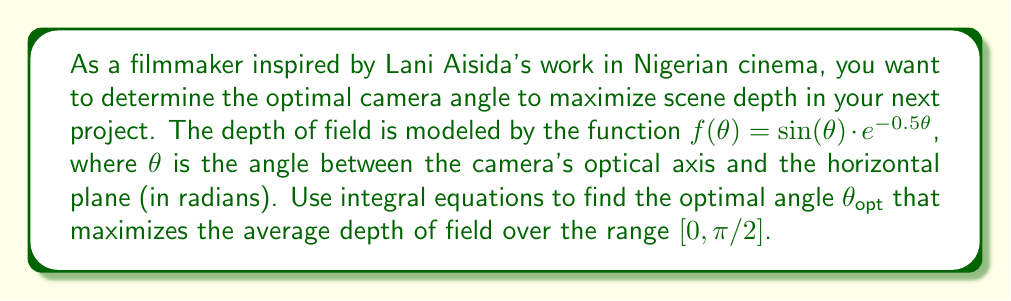What is the answer to this math problem? To find the optimal angle, we need to maximize the average depth of field over the given range. This can be formulated as an integral equation:

1. The average depth of field is given by:
   $$\text{Average Depth} = \frac{1}{\pi/2} \int_0^{\pi/2} f(\theta) d\theta$$

2. Substitute the given function:
   $$\text{Average Depth} = \frac{2}{\pi} \int_0^{\pi/2} \sin(\theta) \cdot e^{-0.5\theta} d\theta$$

3. To find the maximum, we need to differentiate this with respect to $\theta$ and set it to zero:
   $$\frac{d}{d\theta}\left(\frac{2}{\pi} \int_0^{\pi/2} \sin(\theta) \cdot e^{-0.5\theta} d\theta\right) = 0$$

4. Using the Fundamental Theorem of Calculus:
   $$\frac{2}{\pi} \cdot \sin(\theta) \cdot e^{-0.5\theta} = 0$$

5. Solving this equation:
   $$\sin(\theta) \cdot e^{-0.5\theta} = 0$$

6. This is satisfied when $\sin(\theta) = 0$ or when $\theta \to \infty$. In our range $[0, \pi/2]$, $\sin(\theta) = 0$ only at $\theta = 0$.

7. To find the actual maximum (not minimum), we need to find where the derivative of $f(\theta)$ is zero:
   $$f'(\theta) = \cos(\theta) \cdot e^{-0.5\theta} - 0.5 \sin(\theta) \cdot e^{-0.5\theta} = 0$$

8. Simplifying:
   $$\cos(\theta) - 0.5 \sin(\theta) = 0$$
   $$\cot(\theta) = 0.5$$

9. Solving this equation:
   $$\theta_{opt} = \arctan(2) \approx 1.107 \text{ radians} \approx 63.4°$$

This angle maximizes the depth of field function and, consequently, the average depth over the given range.
Answer: $\theta_{opt} = \arctan(2) \approx 1.107 \text{ radians}$ 